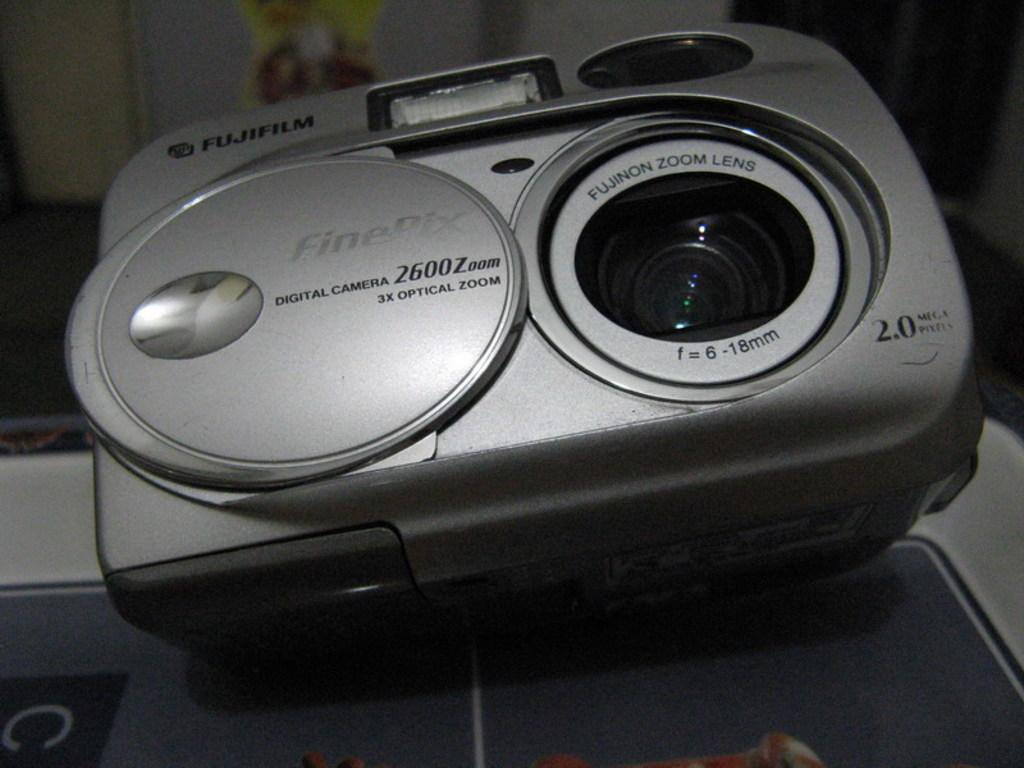What object is the main subject of the image? There is a camera in the image. Where is the camera located in the image? The camera is placed on a surface. What type of shade is covering the camera in the image? There is no shade covering the camera in the image. Can you see any twigs or rocks near the camera in the image? There is no mention of twigs or rocks in the provided facts, so we cannot determine their presence in the image. 